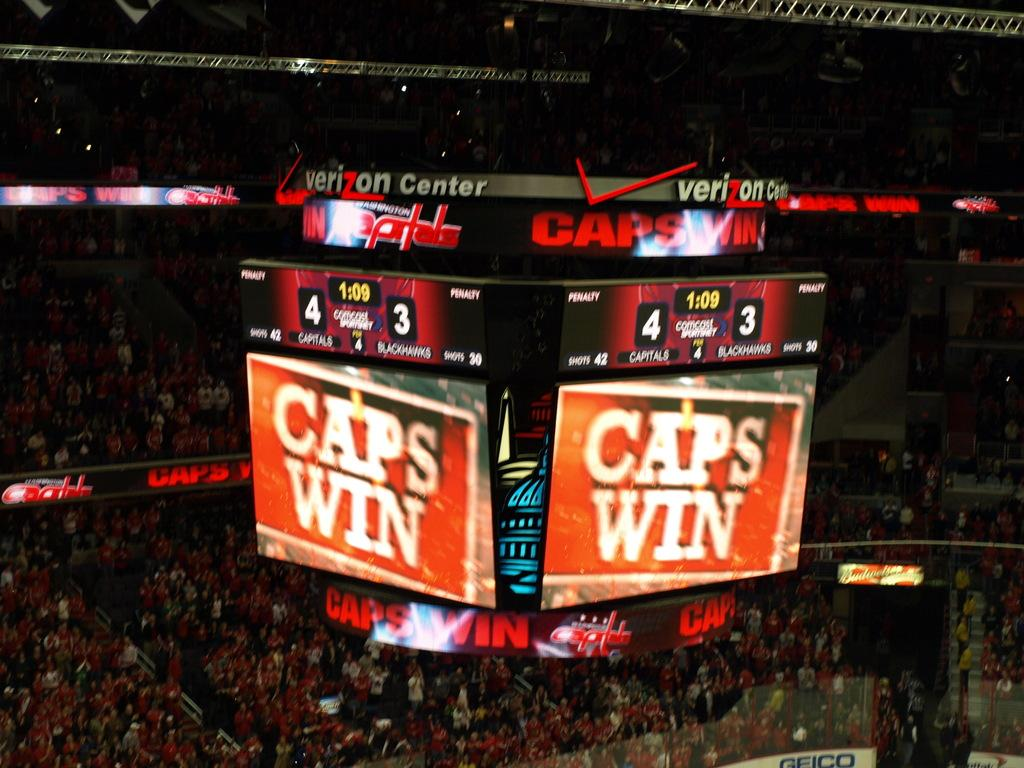What type of location is depicted in the image? The image appears to be a stadium. How many people can be seen in the image? There are many people in the image. What safety feature is present in the image? There are railings in the image. Are there any architectural elements visible in the image? Yes, there are stairs in the image. What type of technology is present in the image? There are screens in the image. What type of signage is present in the image? There are boards with text in the image. Can you tell me what level of the pen the person is holding in the image? There is no pen present in the image, and therefore no such information can be provided. 